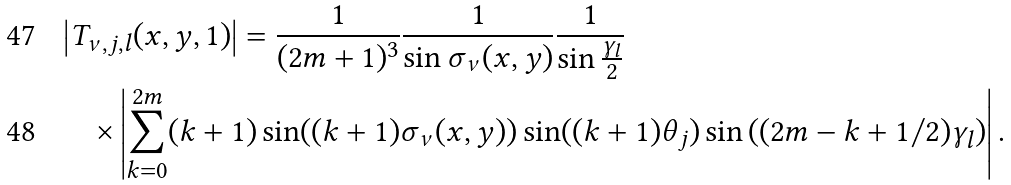<formula> <loc_0><loc_0><loc_500><loc_500>& \left | T _ { \nu , j , l } ( x , y , 1 ) \right | = \frac { 1 } { ( 2 m + 1 ) ^ { 3 } } \frac { 1 } { \sin \sigma _ { \nu } ( x , y ) } \frac { 1 } { \sin \frac { \gamma _ { l } } { 2 } } \\ & \quad \times \left | \sum _ { k = 0 } ^ { 2 m } ( k + 1 ) \sin ( ( k + 1 ) \sigma _ { \nu } ( x , y ) ) \sin ( ( k + 1 ) \theta _ { j } ) \sin \left ( ( 2 m - k + 1 / 2 ) \gamma _ { l } \right ) \right | .</formula> 